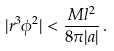Convert formula to latex. <formula><loc_0><loc_0><loc_500><loc_500>| r ^ { 3 } \phi ^ { 2 } | < \frac { M l ^ { 2 } } { 8 \pi | a | } \, .</formula> 